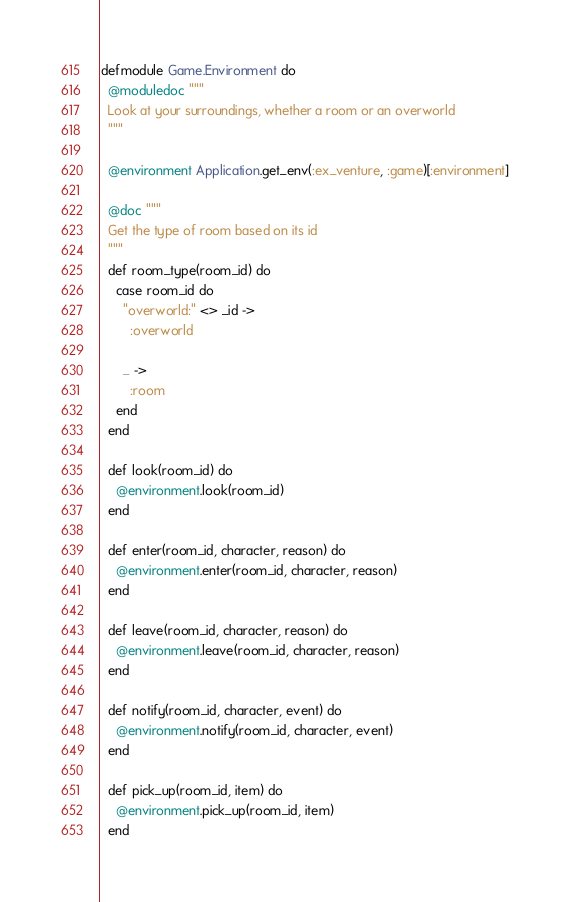Convert code to text. <code><loc_0><loc_0><loc_500><loc_500><_Elixir_>defmodule Game.Environment do
  @moduledoc """
  Look at your surroundings, whether a room or an overworld
  """

  @environment Application.get_env(:ex_venture, :game)[:environment]

  @doc """
  Get the type of room based on its id
  """
  def room_type(room_id) do
    case room_id do
      "overworld:" <> _id ->
        :overworld

      _ ->
        :room
    end
  end

  def look(room_id) do
    @environment.look(room_id)
  end

  def enter(room_id, character, reason) do
    @environment.enter(room_id, character, reason)
  end

  def leave(room_id, character, reason) do
    @environment.leave(room_id, character, reason)
  end

  def notify(room_id, character, event) do
    @environment.notify(room_id, character, event)
  end

  def pick_up(room_id, item) do
    @environment.pick_up(room_id, item)
  end
</code> 